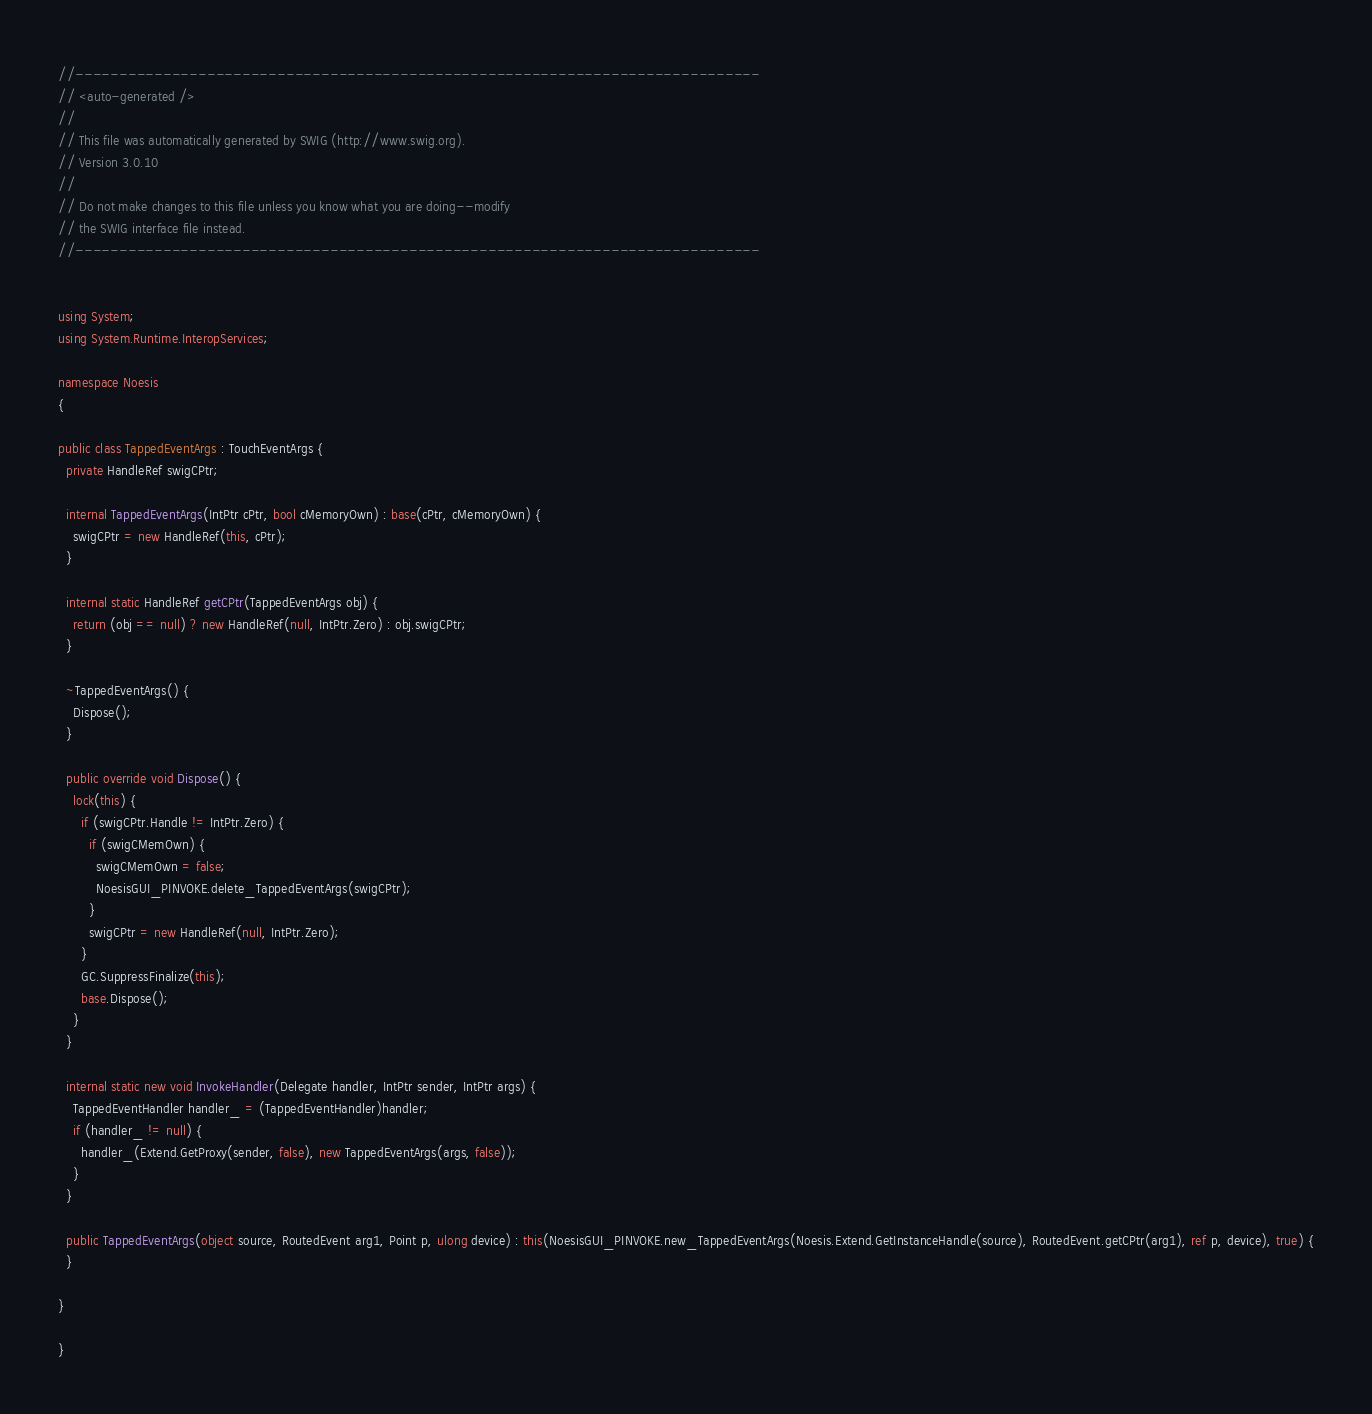Convert code to text. <code><loc_0><loc_0><loc_500><loc_500><_C#_>//------------------------------------------------------------------------------
// <auto-generated />
//
// This file was automatically generated by SWIG (http://www.swig.org).
// Version 3.0.10
//
// Do not make changes to this file unless you know what you are doing--modify
// the SWIG interface file instead.
//------------------------------------------------------------------------------


using System;
using System.Runtime.InteropServices;

namespace Noesis
{

public class TappedEventArgs : TouchEventArgs {
  private HandleRef swigCPtr;

  internal TappedEventArgs(IntPtr cPtr, bool cMemoryOwn) : base(cPtr, cMemoryOwn) {
    swigCPtr = new HandleRef(this, cPtr);
  }

  internal static HandleRef getCPtr(TappedEventArgs obj) {
    return (obj == null) ? new HandleRef(null, IntPtr.Zero) : obj.swigCPtr;
  }

  ~TappedEventArgs() {
    Dispose();
  }

  public override void Dispose() {
    lock(this) {
      if (swigCPtr.Handle != IntPtr.Zero) {
        if (swigCMemOwn) {
          swigCMemOwn = false;
          NoesisGUI_PINVOKE.delete_TappedEventArgs(swigCPtr);
        }
        swigCPtr = new HandleRef(null, IntPtr.Zero);
      }
      GC.SuppressFinalize(this);
      base.Dispose();
    }
  }

  internal static new void InvokeHandler(Delegate handler, IntPtr sender, IntPtr args) {
    TappedEventHandler handler_ = (TappedEventHandler)handler;
    if (handler_ != null) {
      handler_(Extend.GetProxy(sender, false), new TappedEventArgs(args, false));
    }
  }

  public TappedEventArgs(object source, RoutedEvent arg1, Point p, ulong device) : this(NoesisGUI_PINVOKE.new_TappedEventArgs(Noesis.Extend.GetInstanceHandle(source), RoutedEvent.getCPtr(arg1), ref p, device), true) {
  }

}

}

</code> 